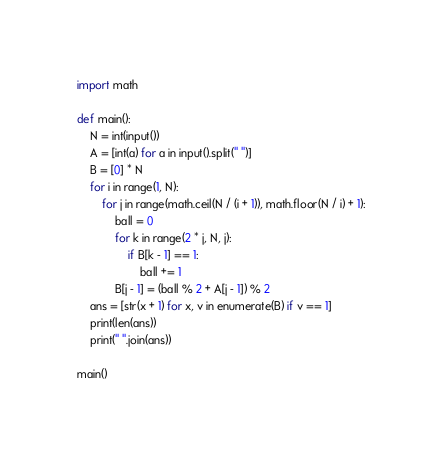<code> <loc_0><loc_0><loc_500><loc_500><_Python_>import math

def main():
	N = int(input())
	A = [int(a) for a in input().split(" ")]
	B = [0] * N
	for i in range(1, N):
		for j in range(math.ceil(N / (i + 1)), math.floor(N / i) + 1):
			ball = 0
			for k in range(2 * j, N, j):
				if B[k - 1] == 1:
					ball += 1
			B[j - 1] = (ball % 2 + A[j - 1]) % 2
	ans = [str(x + 1) for x, v in enumerate(B) if v == 1]
	print(len(ans))
	print(" ".join(ans))

main()
</code> 